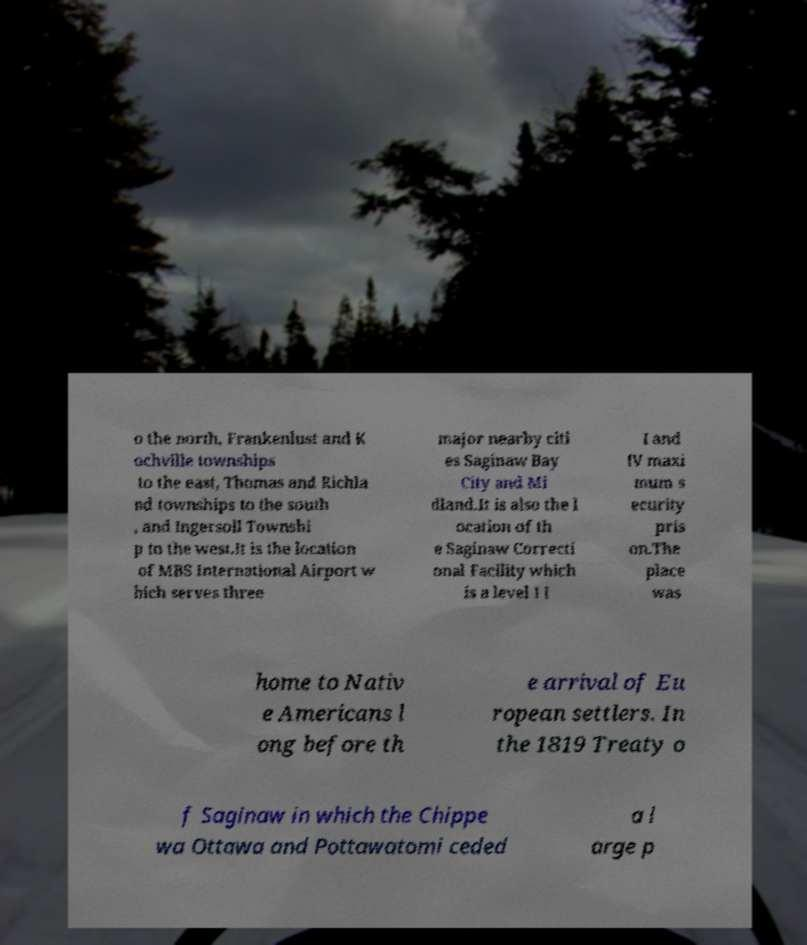I need the written content from this picture converted into text. Can you do that? o the north, Frankenlust and K ochville townships to the east, Thomas and Richla nd townships to the south , and Ingersoll Townshi p to the west.It is the location of MBS International Airport w hich serves three major nearby citi es Saginaw Bay City and Mi dland.It is also the l ocation of th e Saginaw Correcti onal Facility which is a level I I I and IV maxi mum s ecurity pris on.The place was home to Nativ e Americans l ong before th e arrival of Eu ropean settlers. In the 1819 Treaty o f Saginaw in which the Chippe wa Ottawa and Pottawatomi ceded a l arge p 